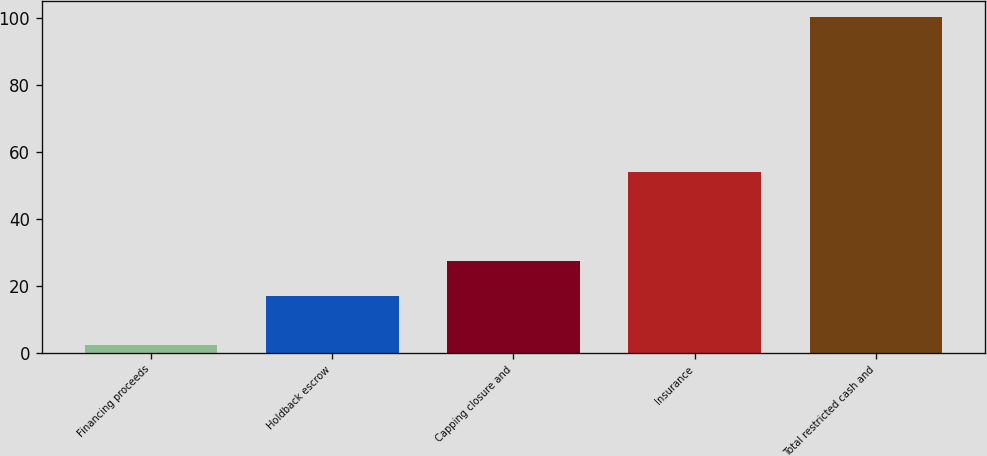<chart> <loc_0><loc_0><loc_500><loc_500><bar_chart><fcel>Financing proceeds<fcel>Holdback escrow<fcel>Capping closure and<fcel>Insurance<fcel>Total restricted cash and<nl><fcel>2.1<fcel>16.8<fcel>27.3<fcel>54.1<fcel>100.3<nl></chart> 